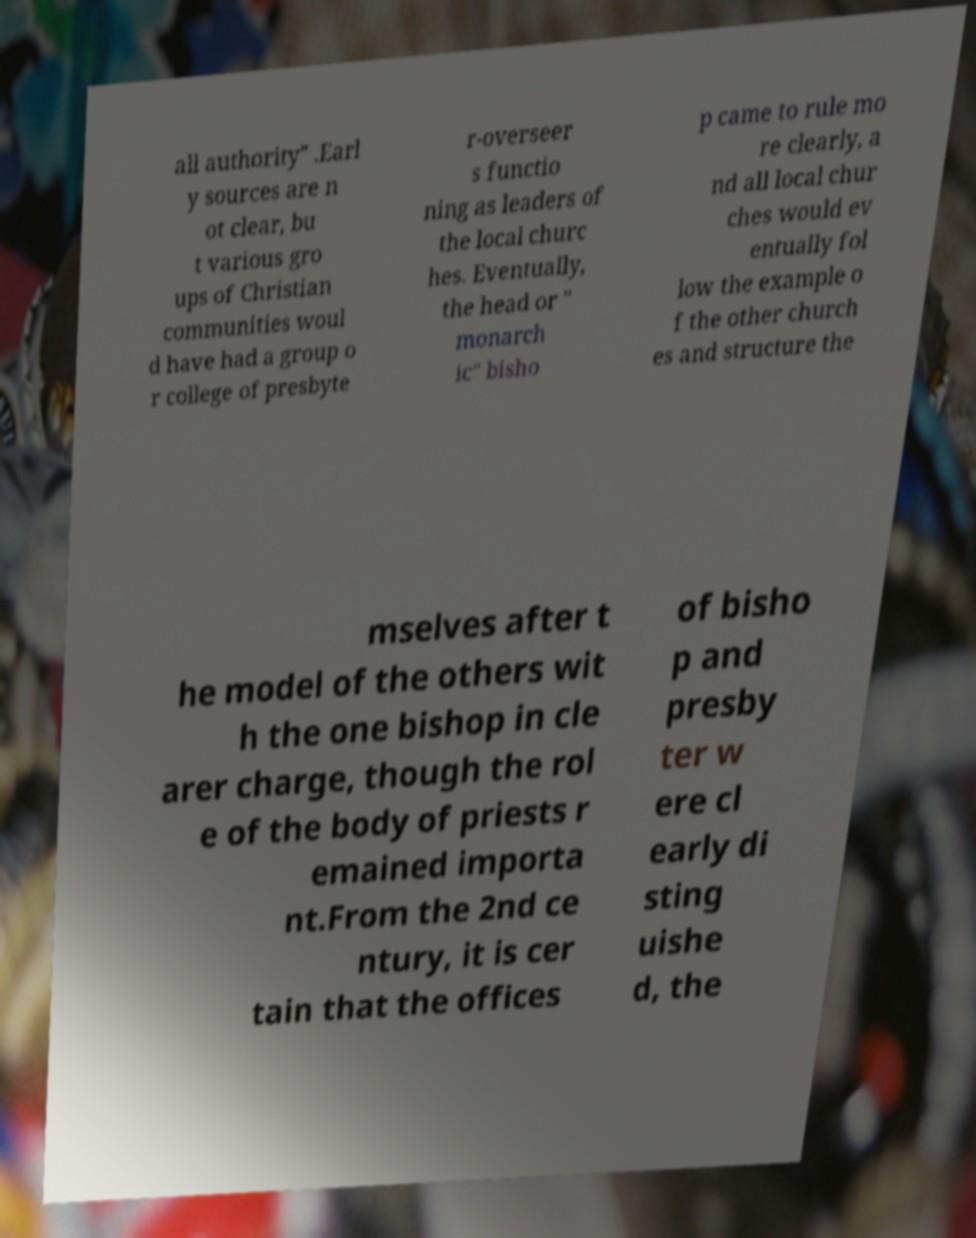Can you read and provide the text displayed in the image?This photo seems to have some interesting text. Can you extract and type it out for me? all authority" .Earl y sources are n ot clear, bu t various gro ups of Christian communities woul d have had a group o r college of presbyte r-overseer s functio ning as leaders of the local churc hes. Eventually, the head or " monarch ic" bisho p came to rule mo re clearly, a nd all local chur ches would ev entually fol low the example o f the other church es and structure the mselves after t he model of the others wit h the one bishop in cle arer charge, though the rol e of the body of priests r emained importa nt.From the 2nd ce ntury, it is cer tain that the offices of bisho p and presby ter w ere cl early di sting uishe d, the 